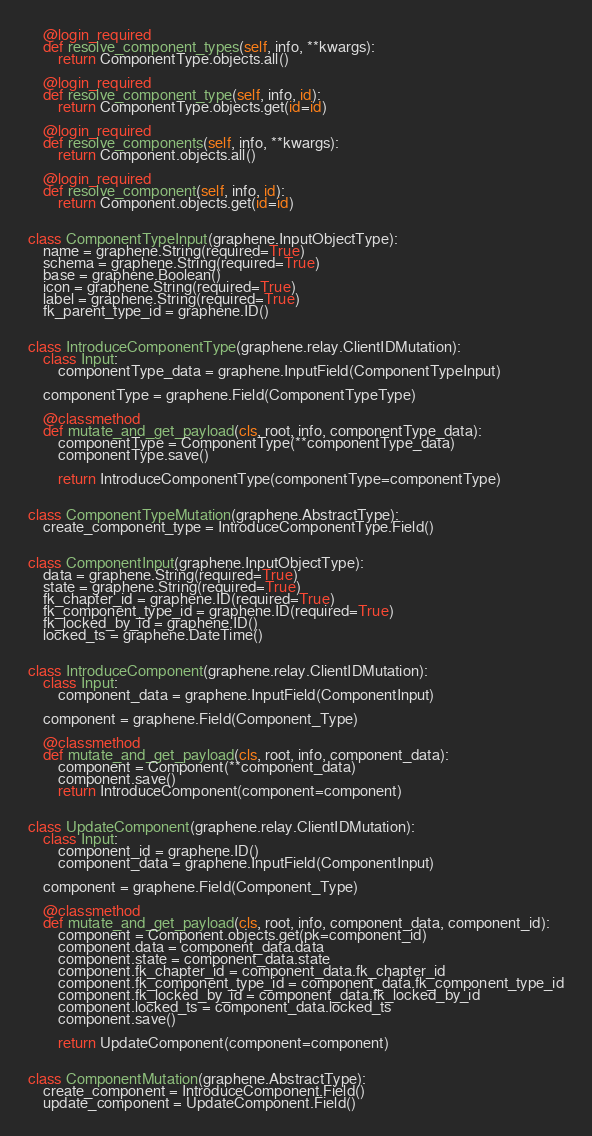Convert code to text. <code><loc_0><loc_0><loc_500><loc_500><_Python_>
    @login_required
    def resolve_component_types(self, info, **kwargs):
        return ComponentType.objects.all()

    @login_required
    def resolve_component_type(self, info, id):
        return ComponentType.objects.get(id=id)

    @login_required
    def resolve_components(self, info, **kwargs):
        return Component.objects.all()

    @login_required
    def resolve_component(self, info, id):
        return Component.objects.get(id=id)


class ComponentTypeInput(graphene.InputObjectType):
    name = graphene.String(required=True)
    schema = graphene.String(required=True)
    base = graphene.Boolean()
    icon = graphene.String(required=True)
    label = graphene.String(required=True)
    fk_parent_type_id = graphene.ID()


class IntroduceComponentType(graphene.relay.ClientIDMutation):
    class Input:
        componentType_data = graphene.InputField(ComponentTypeInput)

    componentType = graphene.Field(ComponentTypeType)

    @classmethod
    def mutate_and_get_payload(cls, root, info, componentType_data):
        componentType = ComponentType(**componentType_data)
        componentType.save()

        return IntroduceComponentType(componentType=componentType)


class ComponentTypeMutation(graphene.AbstractType):
    create_component_type = IntroduceComponentType.Field()


class ComponentInput(graphene.InputObjectType):
    data = graphene.String(required=True)
    state = graphene.String(required=True)
    fk_chapter_id = graphene.ID(required=True)
    fk_component_type_id = graphene.ID(required=True)
    fk_locked_by_id = graphene.ID()
    locked_ts = graphene.DateTime()


class IntroduceComponent(graphene.relay.ClientIDMutation):
    class Input:
        component_data = graphene.InputField(ComponentInput)

    component = graphene.Field(Component_Type)

    @classmethod
    def mutate_and_get_payload(cls, root, info, component_data):
        component = Component(**component_data)
        component.save()
        return IntroduceComponent(component=component)


class UpdateComponent(graphene.relay.ClientIDMutation):
    class Input:
        component_id = graphene.ID()
        component_data = graphene.InputField(ComponentInput)

    component = graphene.Field(Component_Type)

    @classmethod
    def mutate_and_get_payload(cls, root, info, component_data, component_id):
        component = Component.objects.get(pk=component_id)
        component.data = component_data.data
        component.state = component_data.state
        component.fk_chapter_id = component_data.fk_chapter_id
        component.fk_component_type_id = component_data.fk_component_type_id
        component.fk_locked_by_id = component_data.fk_locked_by_id
        component.locked_ts = component_data.locked_ts
        component.save()

        return UpdateComponent(component=component)


class ComponentMutation(graphene.AbstractType):
    create_component = IntroduceComponent.Field()
    update_component = UpdateComponent.Field()
</code> 